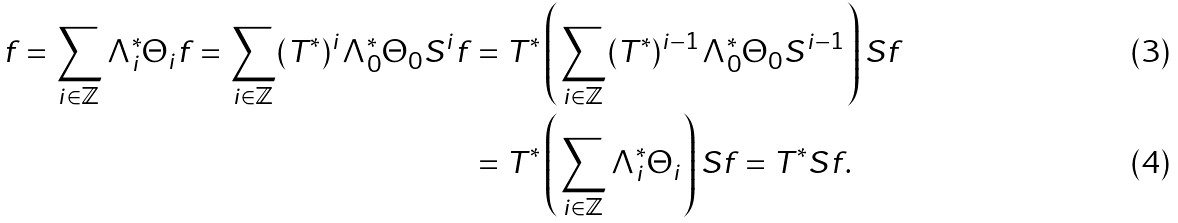Convert formula to latex. <formula><loc_0><loc_0><loc_500><loc_500>f = \sum _ { i \in \mathbb { Z } } \Lambda _ { i } ^ { * } \Theta _ { i } f = \sum _ { i \in \mathbb { Z } } ( T ^ { * } ) ^ { i } \Lambda _ { 0 } ^ { * } \Theta _ { 0 } S ^ { i } f & = T ^ { * } \left ( \sum _ { i \in \mathbb { Z } } ( T ^ { * } ) ^ { i - 1 } \Lambda _ { 0 } ^ { * } \Theta _ { 0 } S ^ { i - 1 } \right ) S f \\ & = T ^ { * } \left ( \sum _ { i \in \mathbb { Z } } \Lambda _ { i } ^ { * } \Theta _ { i } \right ) S f = T ^ { * } S f .</formula> 